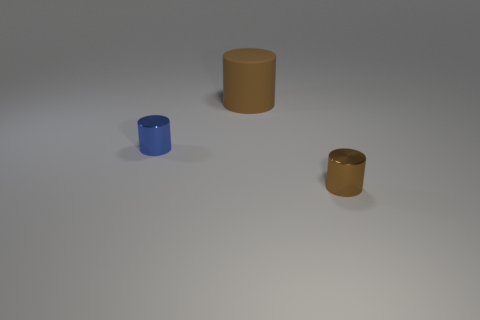Add 2 large rubber things. How many objects exist? 5 Subtract all blue cylinders. How many cylinders are left? 2 Subtract all metal cylinders. How many cylinders are left? 1 Subtract 0 red cylinders. How many objects are left? 3 Subtract 3 cylinders. How many cylinders are left? 0 Subtract all purple cylinders. Subtract all purple spheres. How many cylinders are left? 3 Subtract all blue spheres. How many blue cylinders are left? 1 Subtract all tiny blue cubes. Subtract all brown matte cylinders. How many objects are left? 2 Add 2 big brown objects. How many big brown objects are left? 3 Add 1 big yellow metallic cylinders. How many big yellow metallic cylinders exist? 1 